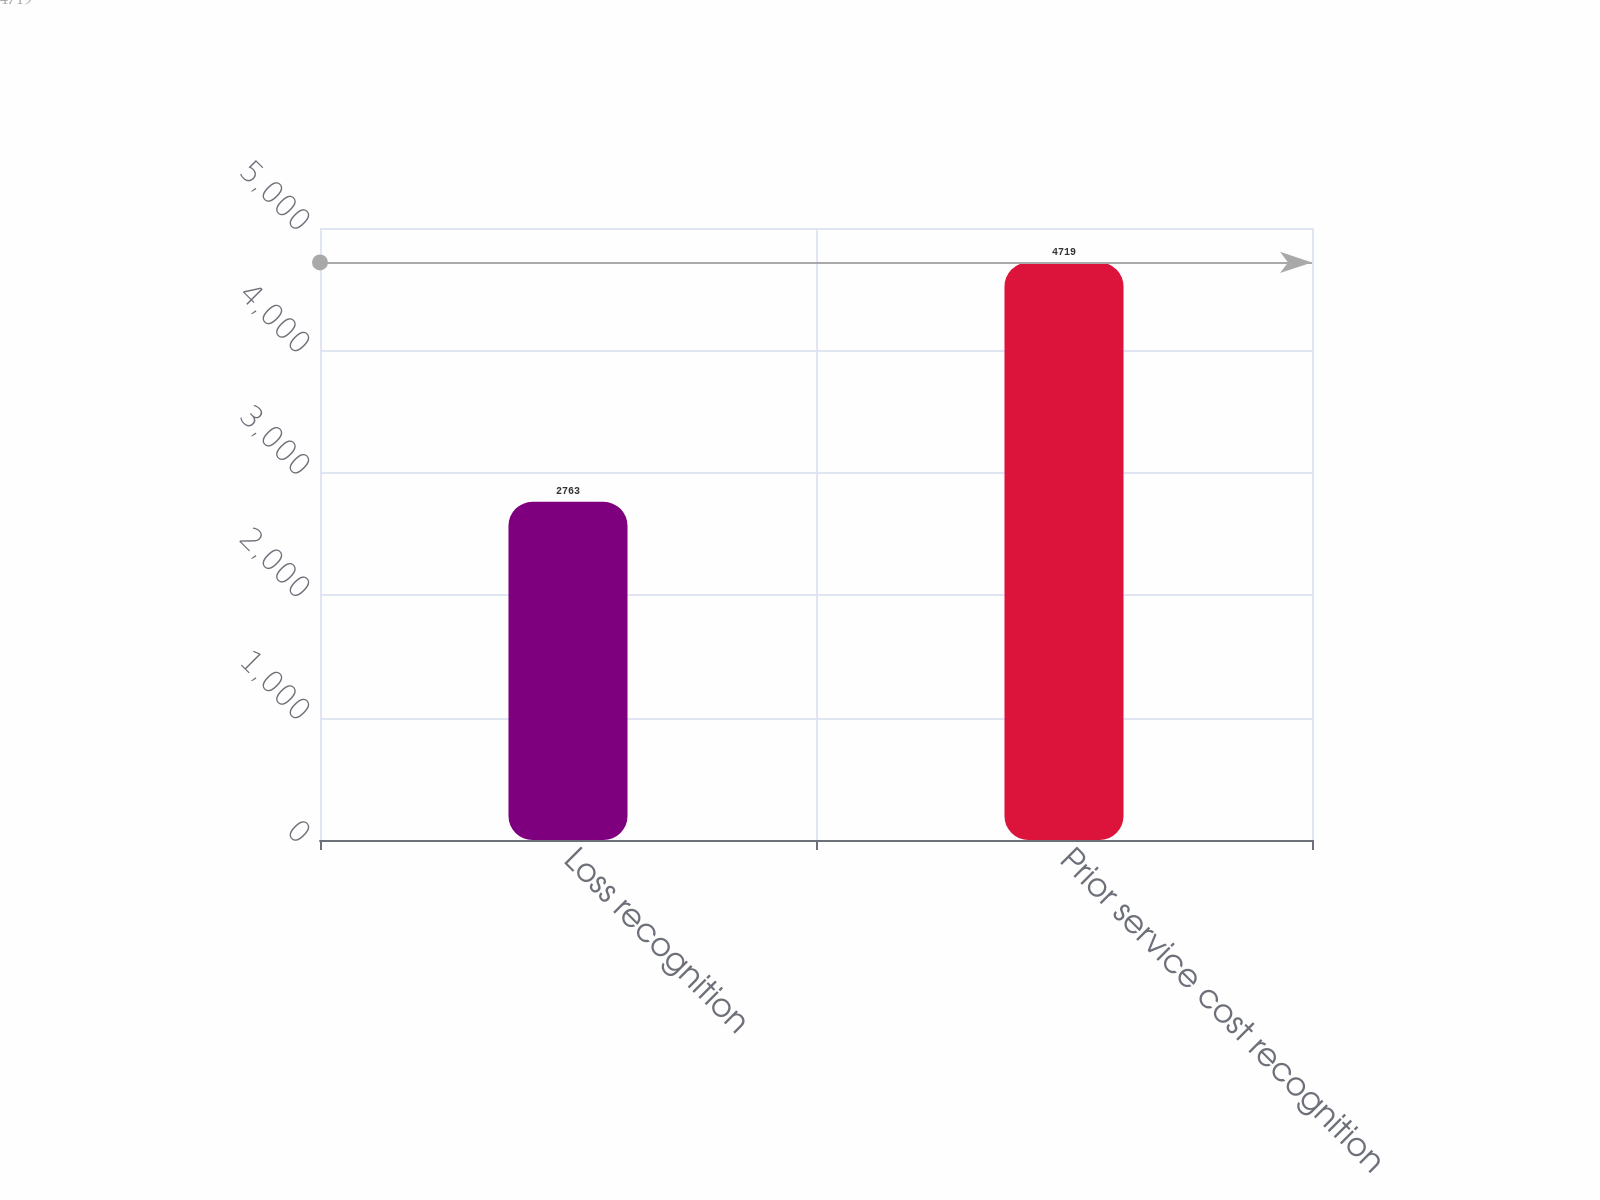Convert chart. <chart><loc_0><loc_0><loc_500><loc_500><bar_chart><fcel>Loss recognition<fcel>Prior service cost recognition<nl><fcel>2763<fcel>4719<nl></chart> 